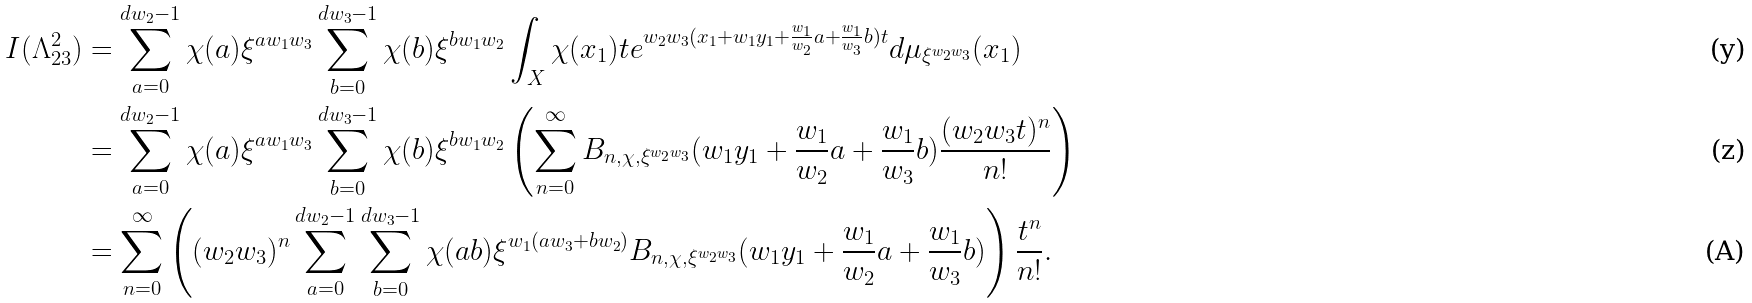Convert formula to latex. <formula><loc_0><loc_0><loc_500><loc_500>I ( \Lambda _ { 2 3 } ^ { 2 } ) & = \sum _ { a = 0 } ^ { d w _ { 2 } - 1 } \chi ( a ) \xi ^ { a w _ { 1 } w _ { 3 } } \sum _ { b = 0 } ^ { d w _ { 3 } - 1 } \chi ( b ) \xi ^ { b w _ { 1 } w _ { 2 } } \int _ { X } { \chi ( x _ { 1 } ) t e ^ { w _ { 2 } w _ { 3 } ( x _ { 1 } + w _ { 1 } y _ { 1 } + \frac { w _ { 1 } } { w _ { 2 } } a + \frac { w _ { 1 } } { w _ { 3 } } b ) t } d \mu _ { \xi ^ { w _ { 2 } w _ { 3 } } } ( x _ { 1 } ) } \\ & = \sum _ { a = 0 } ^ { d w _ { 2 } - 1 } \chi ( a ) \xi ^ { a w _ { 1 } w _ { 3 } } \sum _ { b = 0 } ^ { d w _ { 3 } - 1 } \chi ( b ) \xi ^ { b w _ { 1 } w _ { 2 } } \left ( \sum _ { n = 0 } ^ { \infty } B _ { n , \chi , \xi ^ { w _ { 2 } w _ { 3 } } } ( w _ { 1 } y _ { 1 } + \frac { w _ { 1 } } { w _ { 2 } } a + \frac { w _ { 1 } } { w _ { 3 } } b ) \frac { ( w _ { 2 } w _ { 3 } t ) ^ { n } } { n ! } \right ) \\ & = \sum _ { n = 0 } ^ { \infty } \left ( ( w _ { 2 } w _ { 3 } ) ^ { n } \sum _ { a = 0 } ^ { d w _ { 2 } - 1 } \sum _ { b = 0 } ^ { d w _ { 3 } - 1 } \chi ( a b ) \xi ^ { w _ { 1 } ( a w _ { 3 } + b w _ { 2 } ) } B _ { n , \chi , \xi ^ { w _ { 2 } w _ { 3 } } } ( w _ { 1 } y _ { 1 } + \frac { w _ { 1 } } { w _ { 2 } } a + \frac { w _ { 1 } } { w _ { 3 } } b ) \right ) \frac { t ^ { n } } { n ! } .</formula> 